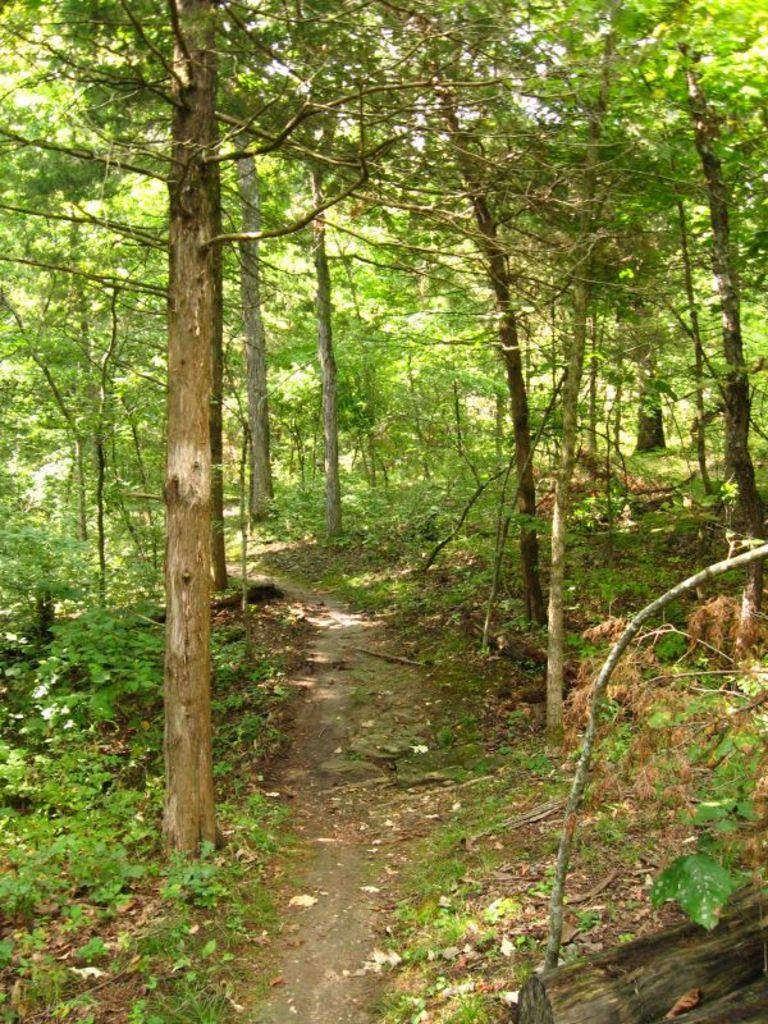What is the main subject of the image? The main subject of the image is a road. What can be seen on both sides of the road? Trees and plants are present on both sides of the road. What type of support does the daughter need in the image? There is no daughter present in the image, so there is no need for support. What type of alarm can be heard in the image? There is no alarm present in the image, so no sound can be heard. 